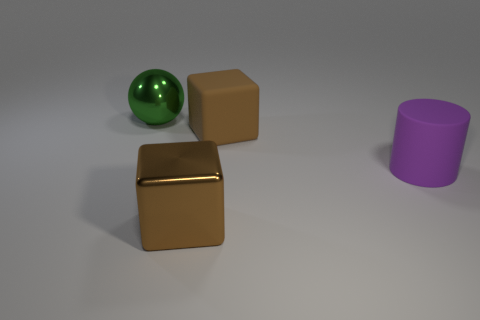Subtract all gray blocks. Subtract all brown cylinders. How many blocks are left? 2 Add 1 tiny green shiny balls. How many objects exist? 5 Subtract all cylinders. How many objects are left? 3 Add 2 big brown shiny cylinders. How many big brown shiny cylinders exist? 2 Subtract 0 blue spheres. How many objects are left? 4 Subtract all large brown shiny objects. Subtract all green shiny balls. How many objects are left? 2 Add 3 big brown blocks. How many big brown blocks are left? 5 